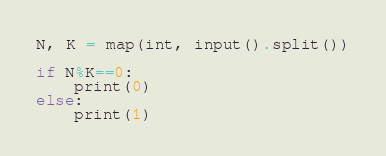Convert code to text. <code><loc_0><loc_0><loc_500><loc_500><_Python_>N, K = map(int, input().split())

if N%K==0:
    print(0)
else:
    print(1)</code> 